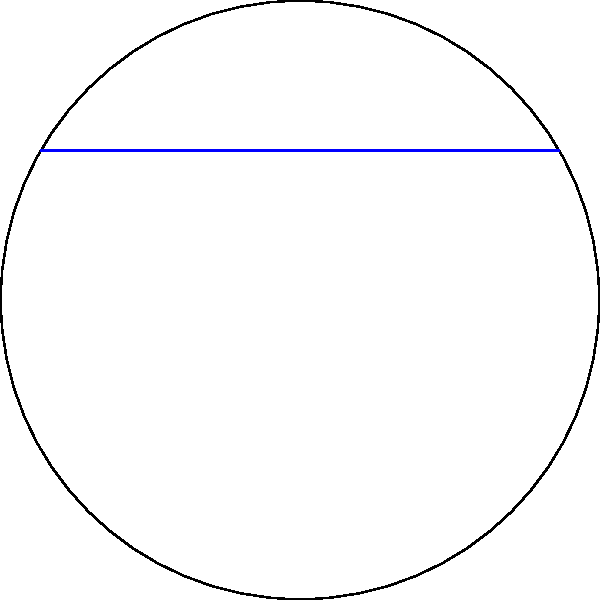Given two points A and B on a globe as shown in the diagram, which path represents the shortest flight route between them? To determine the shortest flight path between two points on a globe, we need to consider the following steps:

1. Recognize that the Earth is approximately spherical.
2. Understand that the shortest distance between two points on a sphere is along a great circle.
3. Identify the two paths shown in the diagram:
   a. The blue straight line represents a rhumb line (constant bearing path).
   b. The red curved line represents a great circle arc.
4. Recall that a great circle is the intersection of a sphere with a plane that passes through the center of the sphere.
5. Observe that the great circle arc (red curve) is shorter than the rhumb line (blue straight line) on the 2D projection.
6. Understand that this 2D projection accurately represents the relationship between these paths on a 3D globe.

The great circle route (red curve) represents the shortest distance between points A and B on the surface of the globe, as it follows the curvature of the Earth. This path is equivalent to the geodesic, or the straightest possible line on a curved surface.

In contrast, the rhumb line (blue straight line) appears shorter on the 2D map projection but would actually be longer when traveling on the surface of the globe.

Therefore, for efficient flight planning, pilots and navigators typically use great circle routes for long-distance flights, adjusting for wind patterns and other factors.
Answer: Great circle route 